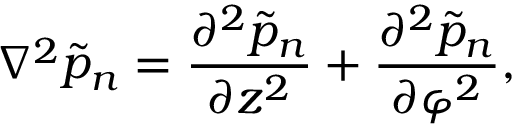Convert formula to latex. <formula><loc_0><loc_0><loc_500><loc_500>\nabla ^ { 2 } \tilde { p } _ { n } = \frac { \partial ^ { 2 } \tilde { p } _ { n } } { \partial z ^ { 2 } } + \frac { \partial ^ { 2 } \tilde { p } _ { n } } { \partial \varphi ^ { 2 } } ,</formula> 